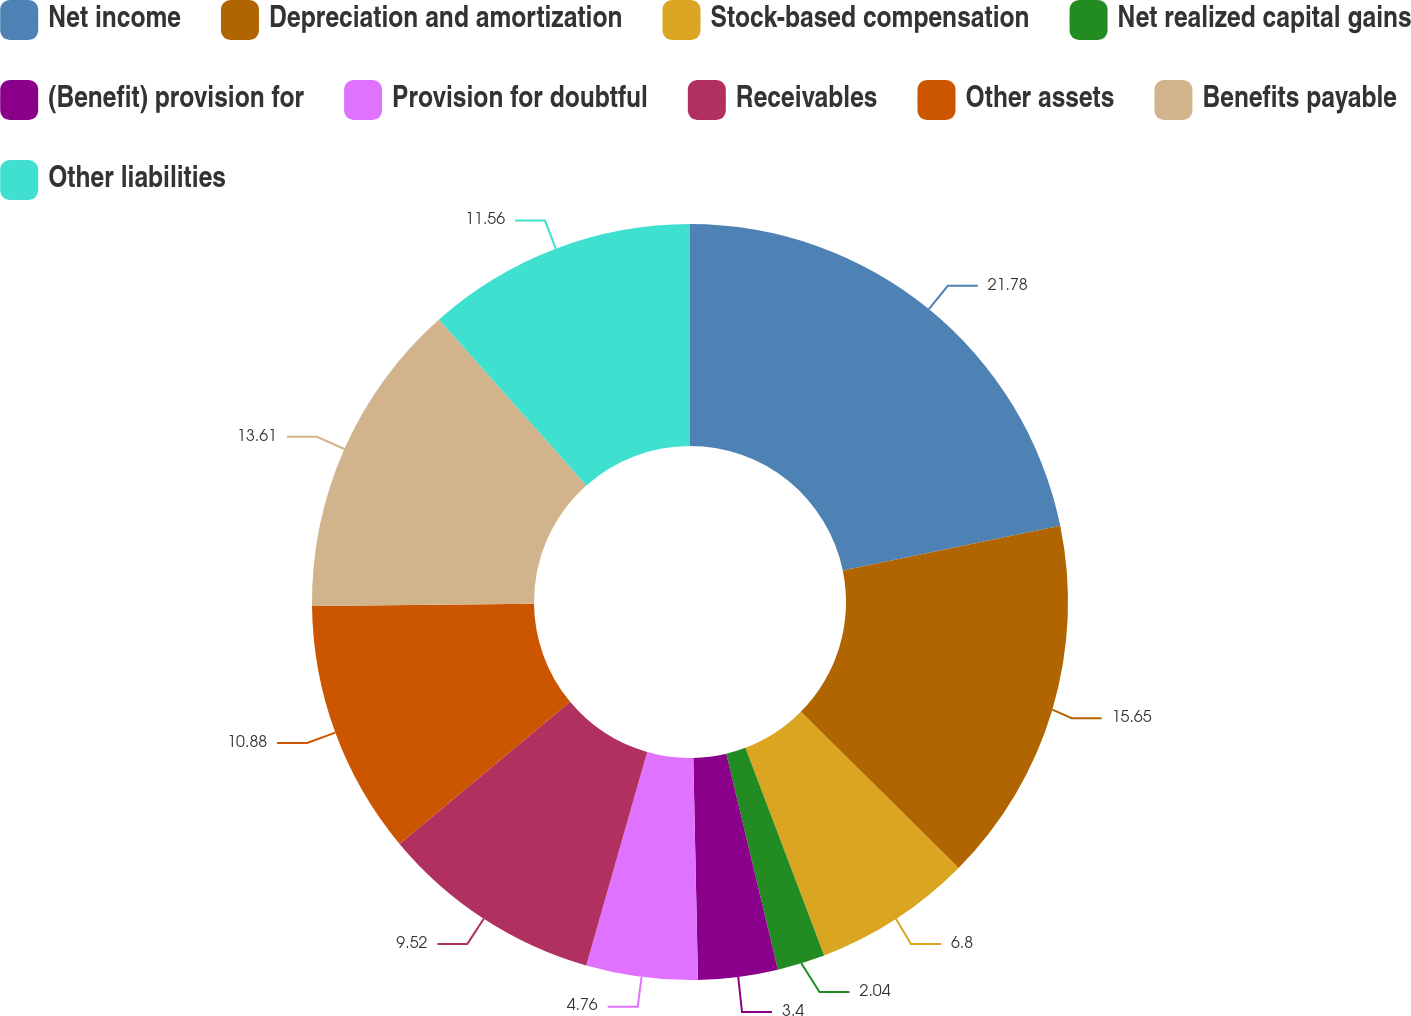Convert chart. <chart><loc_0><loc_0><loc_500><loc_500><pie_chart><fcel>Net income<fcel>Depreciation and amortization<fcel>Stock-based compensation<fcel>Net realized capital gains<fcel>(Benefit) provision for<fcel>Provision for doubtful<fcel>Receivables<fcel>Other assets<fcel>Benefits payable<fcel>Other liabilities<nl><fcel>21.77%<fcel>15.65%<fcel>6.8%<fcel>2.04%<fcel>3.4%<fcel>4.76%<fcel>9.52%<fcel>10.88%<fcel>13.61%<fcel>11.56%<nl></chart> 